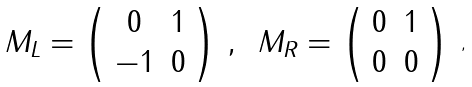<formula> <loc_0><loc_0><loc_500><loc_500>\begin{array} { l l } M _ { L } = \left ( \begin{array} { c c } 0 & 1 \\ - 1 & 0 \end{array} \right ) \, , \, & M _ { R } = \left ( \begin{array} { c c } 0 & 1 \\ 0 & 0 \end{array} \right ) \\ \end{array} \, ,</formula> 